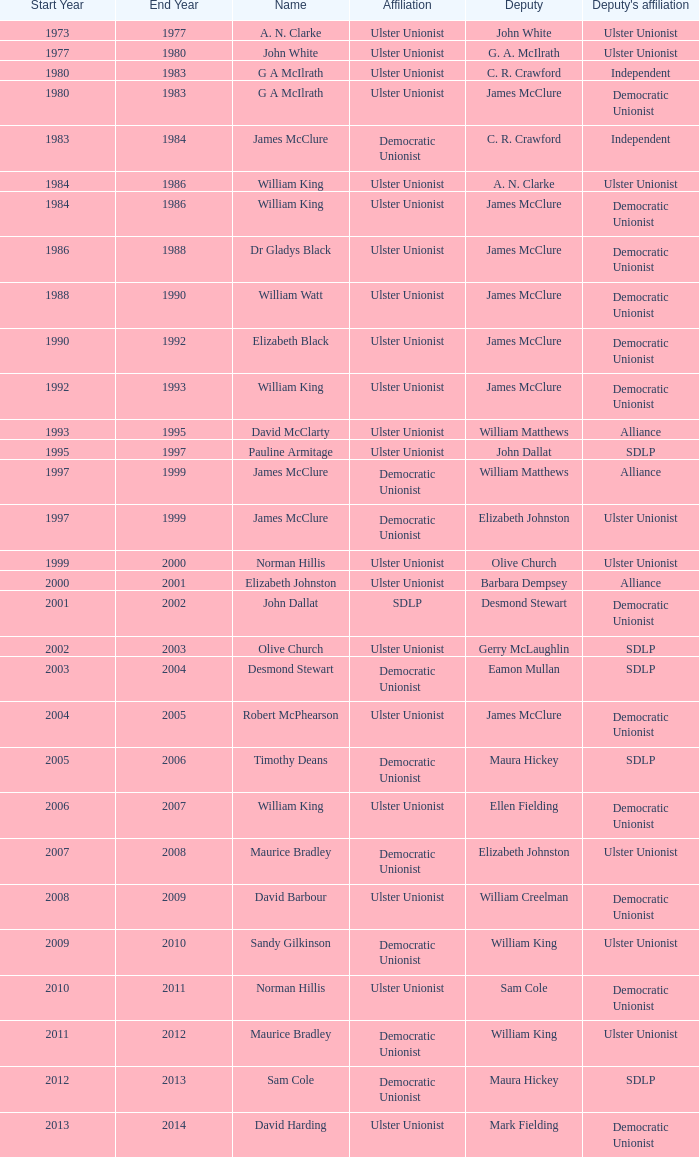What is the name of the Deputy when the Name was elizabeth black? James McClure. 